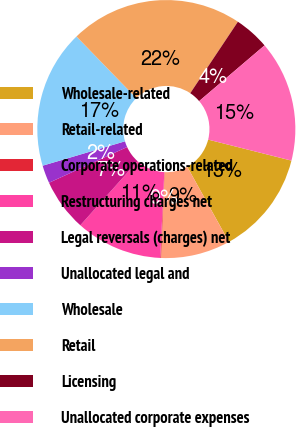Convert chart. <chart><loc_0><loc_0><loc_500><loc_500><pie_chart><fcel>Wholesale-related<fcel>Retail-related<fcel>Corporate operations-related<fcel>Restructuring charges net<fcel>Legal reversals (charges) net<fcel>Unallocated legal and<fcel>Wholesale<fcel>Retail<fcel>Licensing<fcel>Unallocated corporate expenses<nl><fcel>13.01%<fcel>8.71%<fcel>0.1%<fcel>10.86%<fcel>6.56%<fcel>2.25%<fcel>17.32%<fcel>21.62%<fcel>4.41%<fcel>15.16%<nl></chart> 